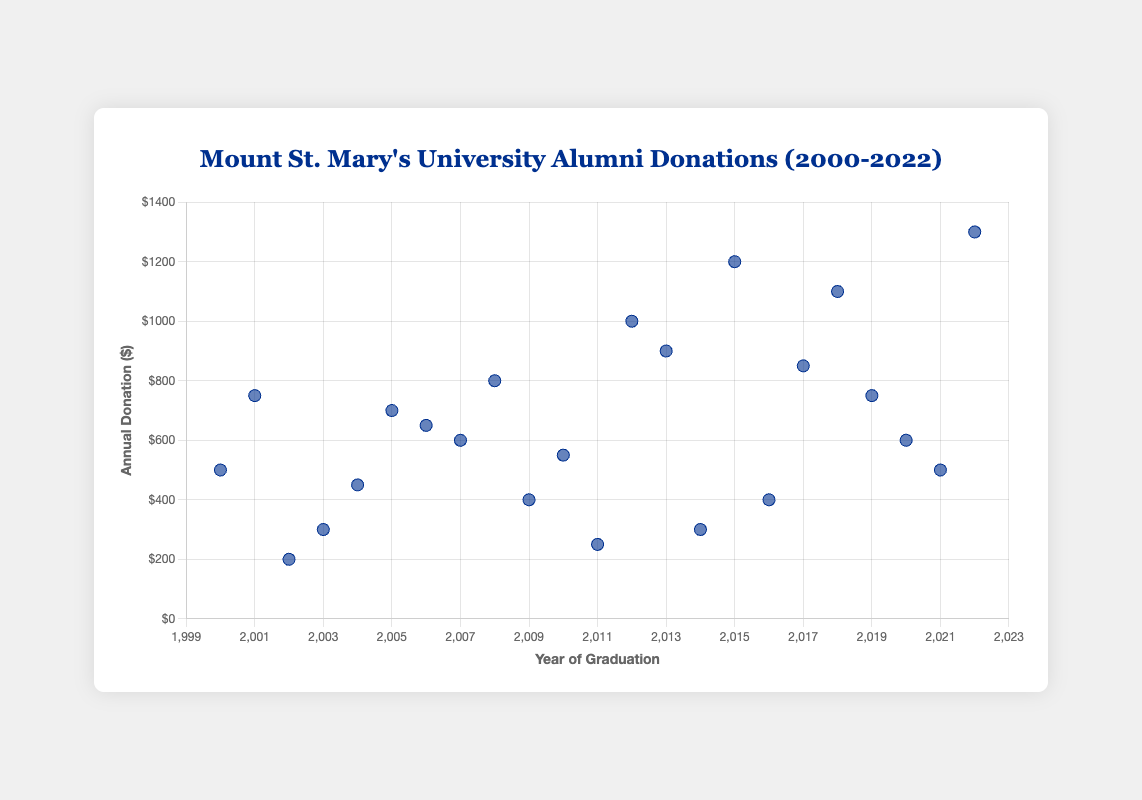What is the title of the scatter plot? The title is typically found at the top of the scatter plot and summarizes the content of the visual representation. It would be written in larger or bold text for easy visibility.
Answer: Mount St. Mary's University Alumni Donations (2000-2022) What does the x-axis represent? The x-axis represents one of the two variables in the scatter plot. In this case, it shows the time-related aspect of the data, specifically each alumnus' year of graduation.
Answer: Year of Graduation What is the highest annual donation amount? Examine the y-axis values and identify the maximum point marked on the scatter plot. This would be the highest vertical point.
Answer: $1300 Which year of graduation had the lowest alumni donation and what was the amount? Find the data point on the scatter plot that is the lowest on the y-axis and check its corresponding x-axis year to determine the year of graduation and amount.
Answer: 2002, $200 How many data points are shown in the scatter plot? Count all the individual points plotted on the scatter plot, representing the data entries. Each point corresponds to one alumnus' donation in a specific year.
Answer: 23 What is the trend in alumni donations from 2018 to 2022? Look at the points from the year 2018 to 2022 on the x-axis and observe the pattern in the y-axis values to detect if they are increasing, decreasing, or remaining constant.
Answer: Increasing How does the donation amount in 2015 compare to that in 2022? Locate the donation points for the years 2015 and 2022 on the scatter plot, then compare their y-axis values to determine which is higher and by how much.
Answer: 2022 is greater by $100 Which year had more alumni who donated more than $1000: 2012 or 2018? Identify the data points for the years 2012 and 2018, then count and compare how many of these points have y-values (donations) greater than $1000.
Answer: 2018 What is the average annual donation for the years 2000, 2005, and 2010? Locate the points corresponding to the years 2000, 2005, and 2010, sum their y-values (donations), and then divide by the number of years to find the average.
Answer: ($500 + $700 + $550) / 3 = $583.33 What is the overall trend in alumni donations over the years? Look at the scatter plot as a whole and determine whether there is a general pattern in the data points, such as an upward, downward, or no clear trend.
Answer: Mixed trend 